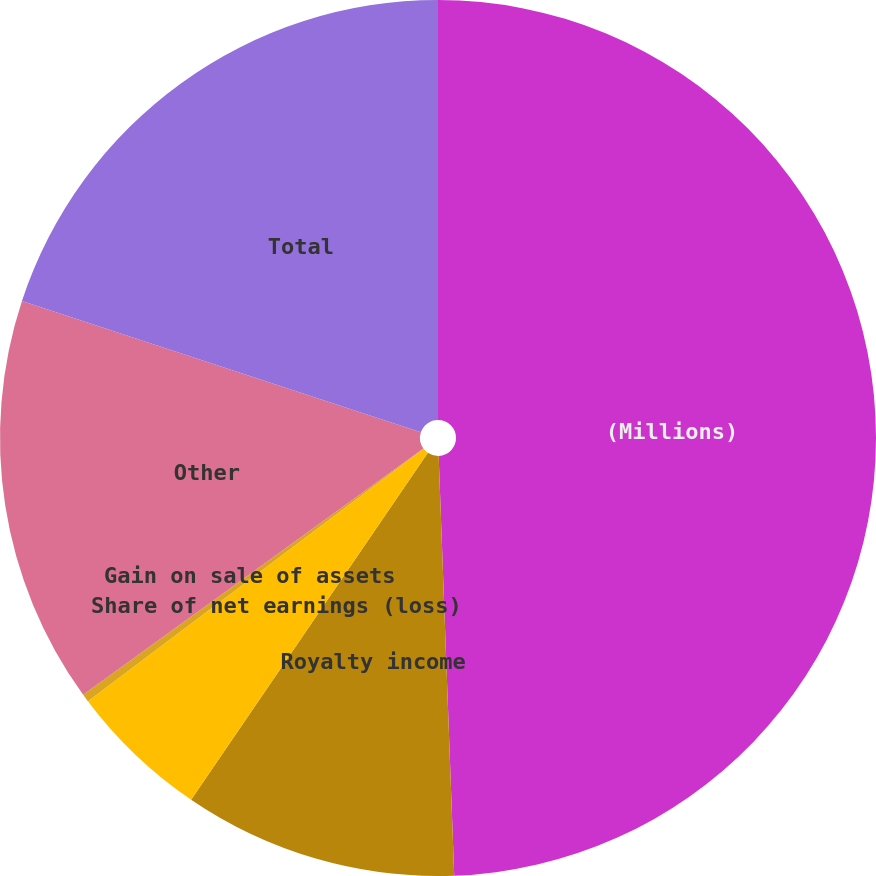Convert chart. <chart><loc_0><loc_0><loc_500><loc_500><pie_chart><fcel>(Millions)<fcel>Royalty income<fcel>Share of net earnings (loss)<fcel>Gain on sale of assets<fcel>Other<fcel>Total<nl><fcel>49.41%<fcel>10.12%<fcel>5.21%<fcel>0.29%<fcel>15.03%<fcel>19.94%<nl></chart> 